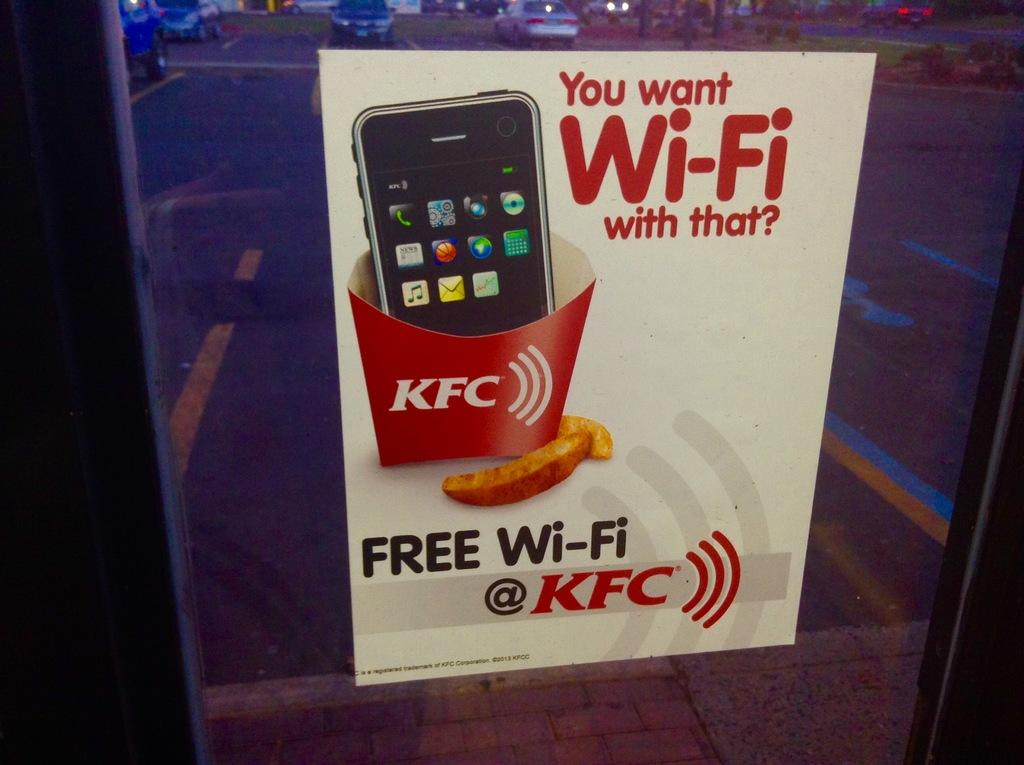Provide a one-sentence caption for the provided image. A sign advertising the availability of free wi-fi access at a KFC. 